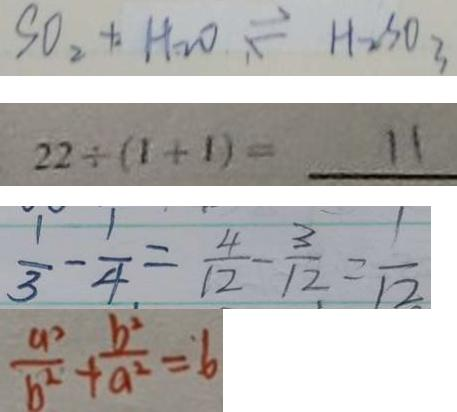<formula> <loc_0><loc_0><loc_500><loc_500>S O _ { 2 } + H _ { 2 } O \rightleftharpoons H _ { 2 } S O _ { 3 } 
 2 2 \div ( 1 + 1 ) = 1 1 
 \frac { 1 } { 3 } - \frac { 1 } { 4 } = \frac { 4 } { 1 2 } - \frac { 3 } { 1 2 } = \frac { 1 } { 1 2 } 
 \frac { a ^ { 2 } } { b ^ { 2 } } + \frac { b ^ { 2 } } { a ^ { 2 } } = 6</formula> 